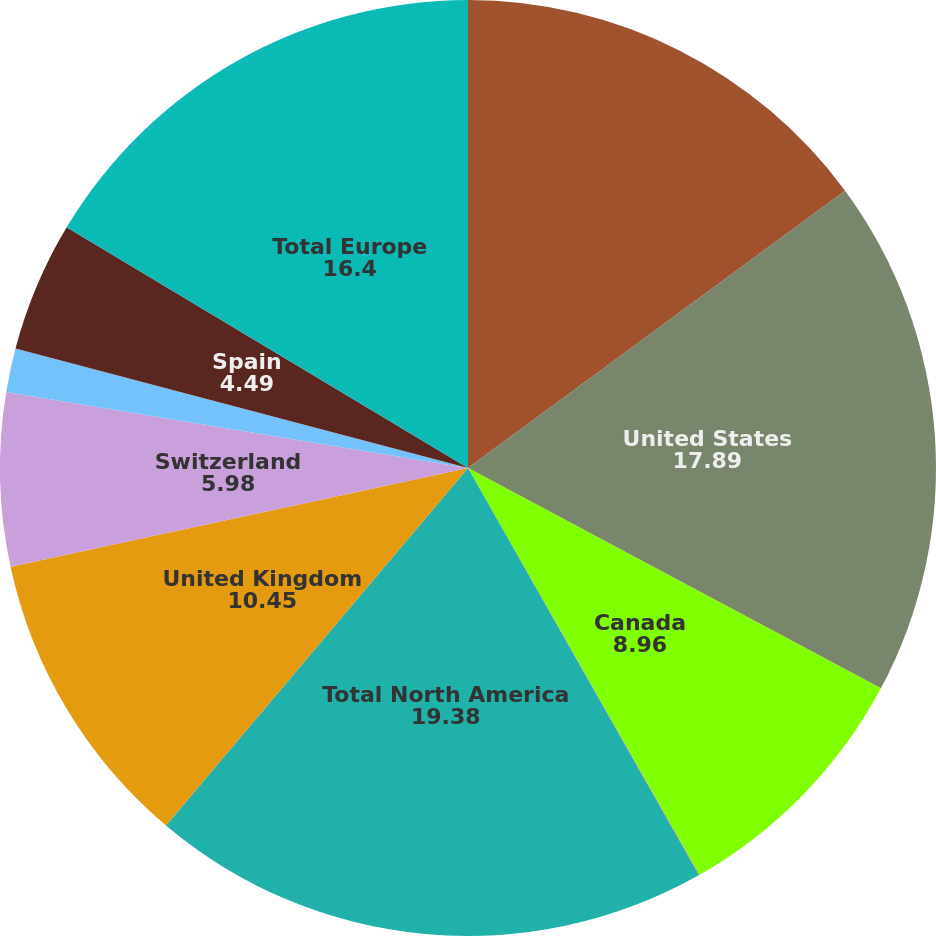<chart> <loc_0><loc_0><loc_500><loc_500><pie_chart><fcel>Year Ended December 31<fcel>United States<fcel>Canada<fcel>Other<fcel>Total North America<fcel>United Kingdom<fcel>Switzerland<fcel>Russia<fcel>Spain<fcel>Total Europe<nl><fcel>14.91%<fcel>17.89%<fcel>8.96%<fcel>0.02%<fcel>19.38%<fcel>10.45%<fcel>5.98%<fcel>1.51%<fcel>4.49%<fcel>16.4%<nl></chart> 